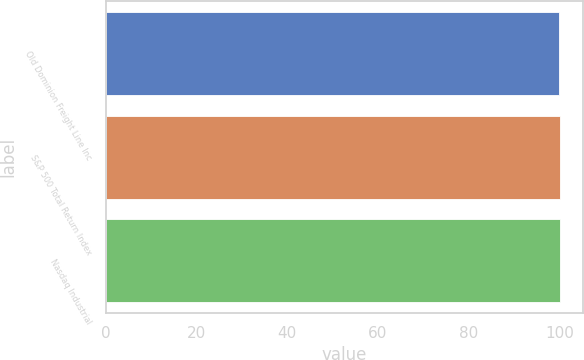Convert chart to OTSL. <chart><loc_0><loc_0><loc_500><loc_500><bar_chart><fcel>Old Dominion Freight Line Inc<fcel>S&P 500 Total Return Index<fcel>Nasdaq Industrial<nl><fcel>100<fcel>100.1<fcel>100.2<nl></chart> 